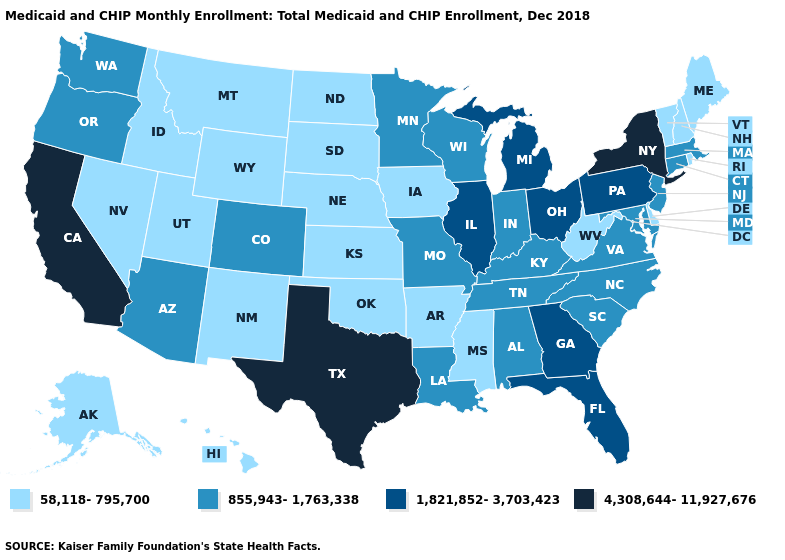Does New Jersey have the highest value in the Northeast?
Answer briefly. No. Among the states that border New Jersey , does Pennsylvania have the highest value?
Be succinct. No. Name the states that have a value in the range 4,308,644-11,927,676?
Concise answer only. California, New York, Texas. Does Montana have the highest value in the USA?
Keep it brief. No. Which states have the highest value in the USA?
Quick response, please. California, New York, Texas. What is the lowest value in the USA?
Short answer required. 58,118-795,700. Does Oregon have a lower value than Tennessee?
Give a very brief answer. No. What is the value of Oklahoma?
Give a very brief answer. 58,118-795,700. Which states have the lowest value in the USA?
Concise answer only. Alaska, Arkansas, Delaware, Hawaii, Idaho, Iowa, Kansas, Maine, Mississippi, Montana, Nebraska, Nevada, New Hampshire, New Mexico, North Dakota, Oklahoma, Rhode Island, South Dakota, Utah, Vermont, West Virginia, Wyoming. What is the highest value in states that border Kansas?
Give a very brief answer. 855,943-1,763,338. Does Massachusetts have the lowest value in the Northeast?
Keep it brief. No. Name the states that have a value in the range 58,118-795,700?
Short answer required. Alaska, Arkansas, Delaware, Hawaii, Idaho, Iowa, Kansas, Maine, Mississippi, Montana, Nebraska, Nevada, New Hampshire, New Mexico, North Dakota, Oklahoma, Rhode Island, South Dakota, Utah, Vermont, West Virginia, Wyoming. Among the states that border Kansas , does Missouri have the lowest value?
Answer briefly. No. Name the states that have a value in the range 58,118-795,700?
Write a very short answer. Alaska, Arkansas, Delaware, Hawaii, Idaho, Iowa, Kansas, Maine, Mississippi, Montana, Nebraska, Nevada, New Hampshire, New Mexico, North Dakota, Oklahoma, Rhode Island, South Dakota, Utah, Vermont, West Virginia, Wyoming. Among the states that border Idaho , which have the highest value?
Keep it brief. Oregon, Washington. 